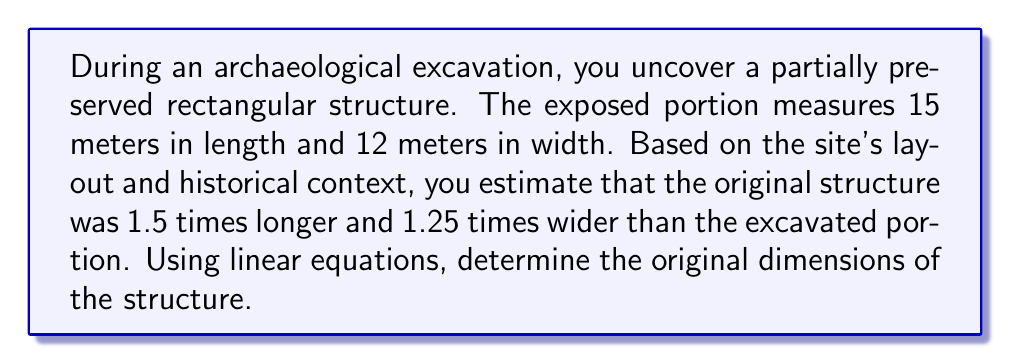Give your solution to this math problem. Let's approach this step-by-step:

1) Let $x$ be the original length and $y$ be the original width of the structure.

2) We can set up two linear equations based on the given information:

   For the length: $x = 1.5 \cdot 15$
   For the width: $y = 1.25 \cdot 12$

3) Solving for $x$:
   $$x = 1.5 \cdot 15 = 22.5$$

4) Solving for $y$:
   $$y = 1.25 \cdot 12 = 15$$

5) Therefore, the original dimensions of the structure were 22.5 meters in length and 15 meters in width.

To verify, we can check that:
   22.5 / 15 = 1.5 (length ratio)
   15 / 12 = 1.25 (width ratio)

These ratios match the given information, confirming our calculation.
Answer: 22.5 m × 15 m 